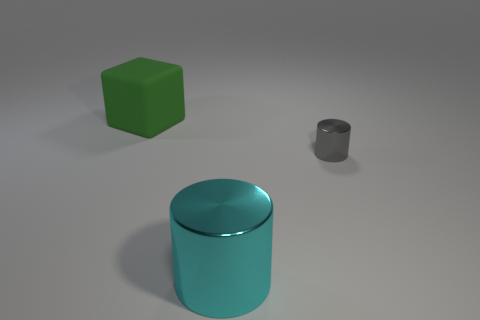How might the different objects be used in a lesson about geometry? These objects are excellent for a geometry lesson. The green cube can be used to discuss squares, cubes, and the concept of area versus volume. The large cyan cylinder would be ideal for explaining circles, cylinders, and the calculation of curved surface areas. Lastly, the smaller grey cylinder can serve as a contrast in scale, showing how dimensions affect volume and surface area even with similar shapes. 